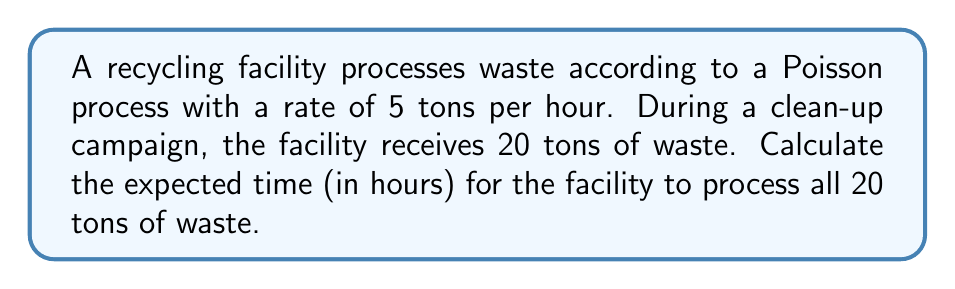Can you solve this math problem? To solve this problem, we'll use the properties of the Poisson process:

1) In a Poisson process, the number of events (in this case, tons of waste processed) in a given time interval follows a Poisson distribution.

2) The time between events in a Poisson process follows an exponential distribution.

3) For a Poisson process with rate $\lambda$, the expected time for $n$ events to occur is $\frac{n}{\lambda}$.

Given:
- Rate of processing: $\lambda = 5$ tons per hour
- Amount of waste to process: $n = 20$ tons

The expected time $T$ to process 20 tons of waste is:

$$T = \frac{n}{\lambda} = \frac{20}{5} = 4$$

Therefore, the expected time for the recycling facility to process 20 tons of waste is 4 hours.

Note: This result is based on the long-term average. In reality, due to the randomness of the Poisson process, the actual time might be shorter or longer, but on average, it will be 4 hours.
Answer: 4 hours 